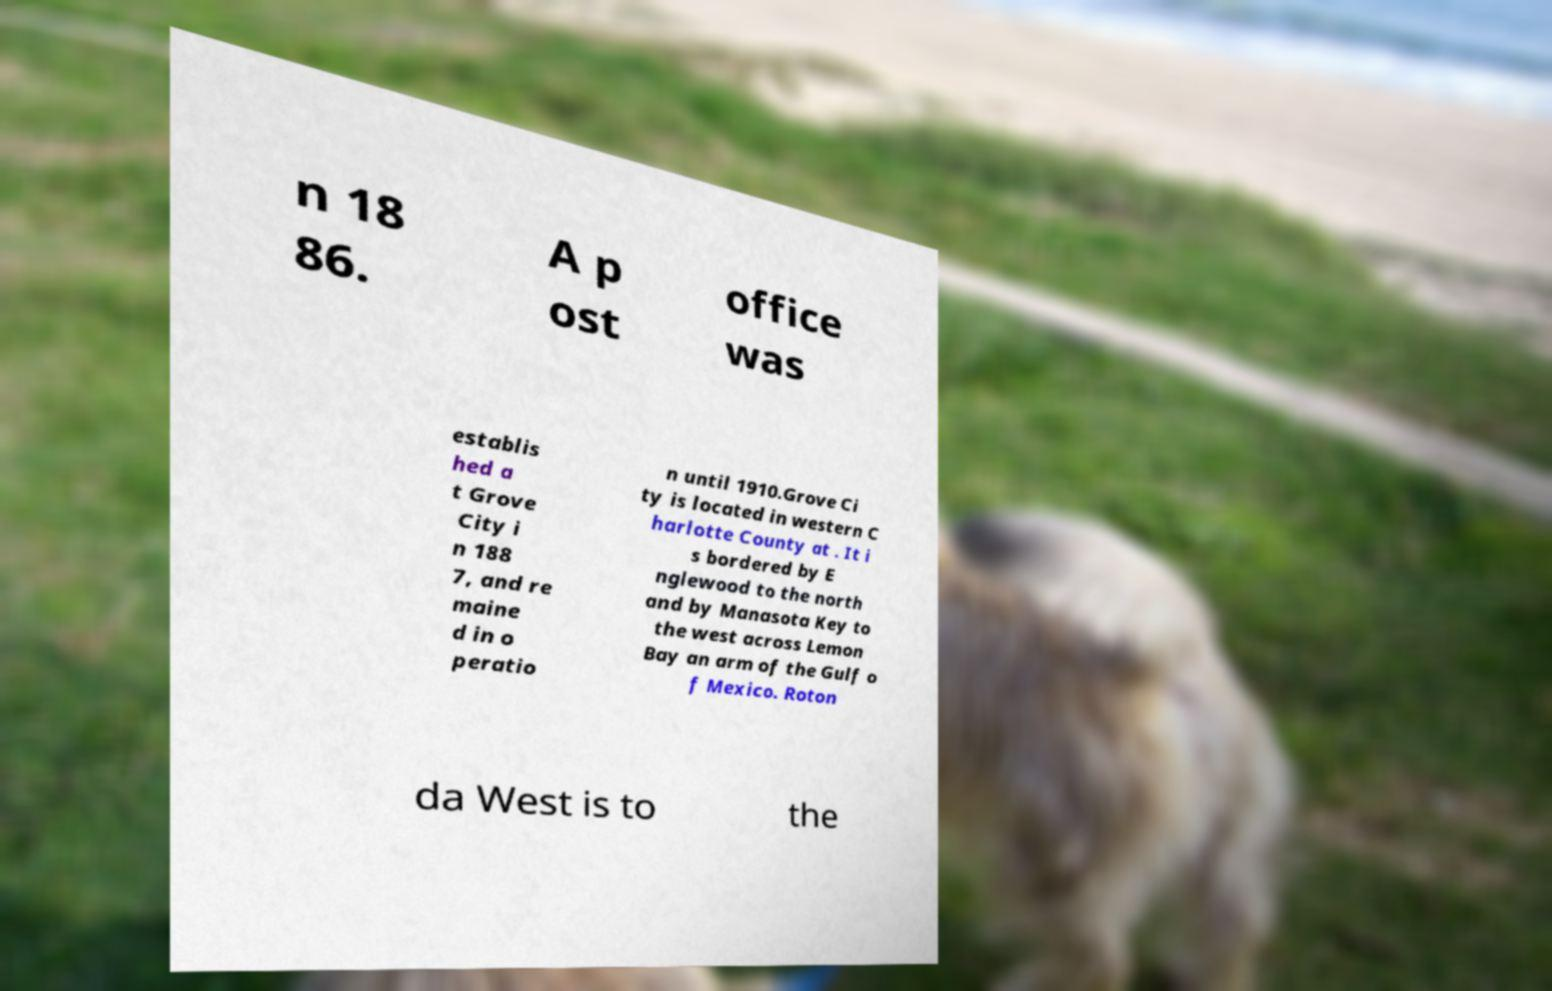For documentation purposes, I need the text within this image transcribed. Could you provide that? n 18 86. A p ost office was establis hed a t Grove City i n 188 7, and re maine d in o peratio n until 1910.Grove Ci ty is located in western C harlotte County at . It i s bordered by E nglewood to the north and by Manasota Key to the west across Lemon Bay an arm of the Gulf o f Mexico. Roton da West is to the 